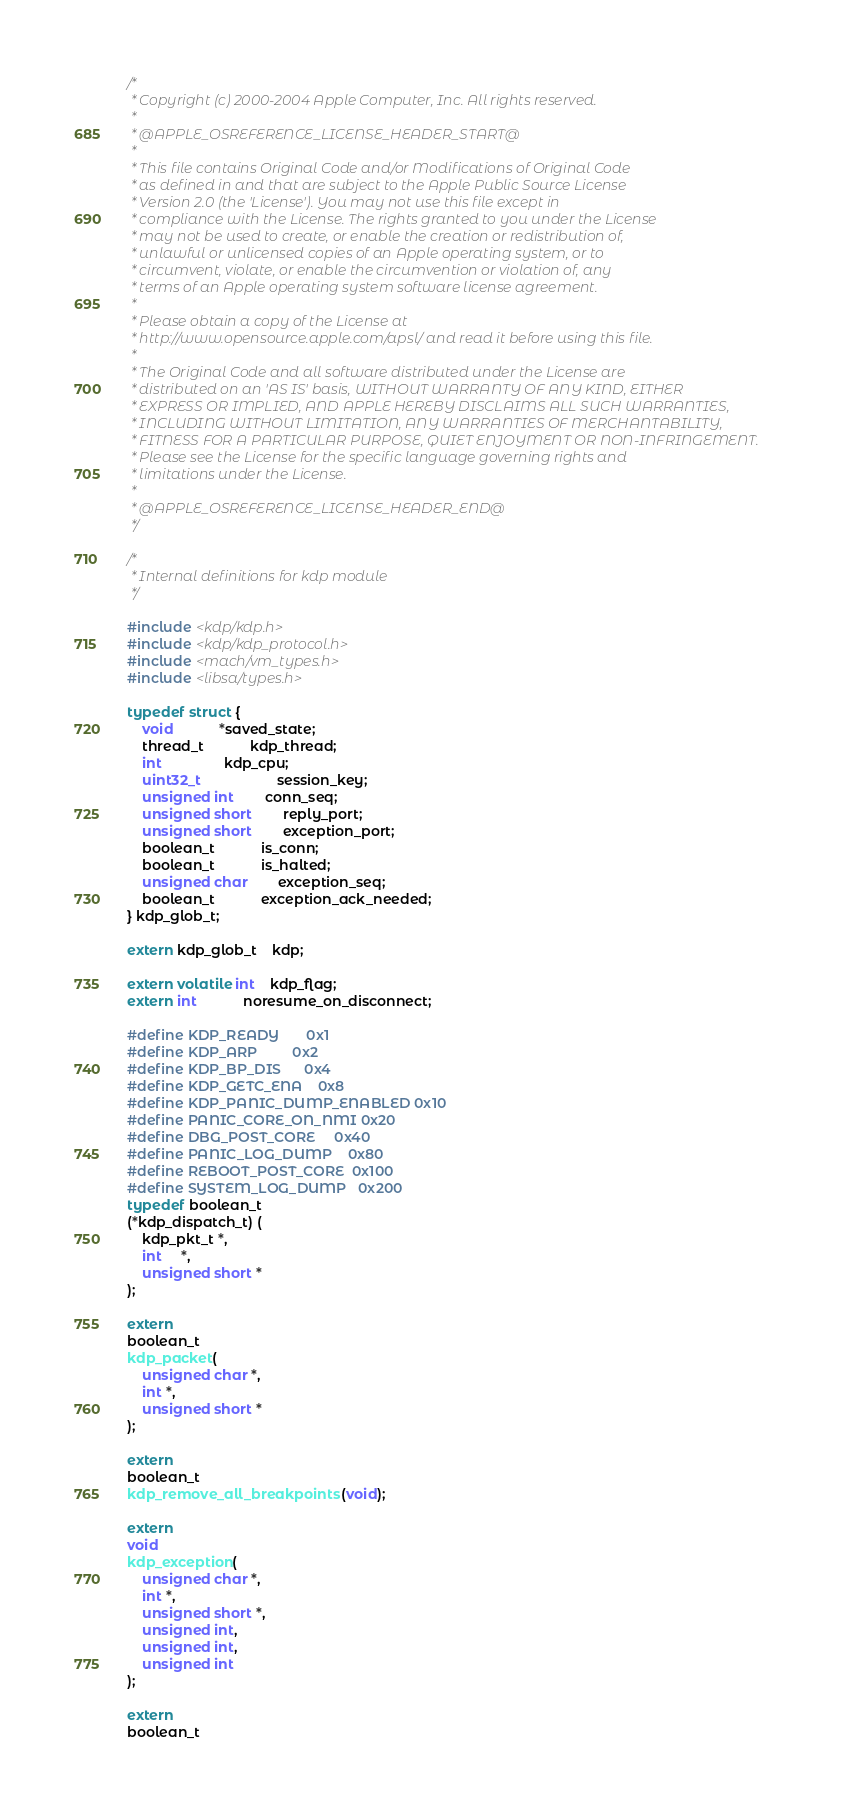Convert code to text. <code><loc_0><loc_0><loc_500><loc_500><_C_>/*
 * Copyright (c) 2000-2004 Apple Computer, Inc. All rights reserved.
 *
 * @APPLE_OSREFERENCE_LICENSE_HEADER_START@
 * 
 * This file contains Original Code and/or Modifications of Original Code
 * as defined in and that are subject to the Apple Public Source License
 * Version 2.0 (the 'License'). You may not use this file except in
 * compliance with the License. The rights granted to you under the License
 * may not be used to create, or enable the creation or redistribution of,
 * unlawful or unlicensed copies of an Apple operating system, or to
 * circumvent, violate, or enable the circumvention or violation of, any
 * terms of an Apple operating system software license agreement.
 * 
 * Please obtain a copy of the License at
 * http://www.opensource.apple.com/apsl/ and read it before using this file.
 * 
 * The Original Code and all software distributed under the License are
 * distributed on an 'AS IS' basis, WITHOUT WARRANTY OF ANY KIND, EITHER
 * EXPRESS OR IMPLIED, AND APPLE HEREBY DISCLAIMS ALL SUCH WARRANTIES,
 * INCLUDING WITHOUT LIMITATION, ANY WARRANTIES OF MERCHANTABILITY,
 * FITNESS FOR A PARTICULAR PURPOSE, QUIET ENJOYMENT OR NON-INFRINGEMENT.
 * Please see the License for the specific language governing rights and
 * limitations under the License.
 * 
 * @APPLE_OSREFERENCE_LICENSE_HEADER_END@
 */

/*
 * Internal definitions for kdp module
 */

#include <kdp/kdp.h>
#include <kdp/kdp_protocol.h>
#include <mach/vm_types.h>
#include <libsa/types.h>

typedef struct {
    void			*saved_state;
    thread_t			kdp_thread;
    int				kdp_cpu;
    uint32_t                    session_key;
    unsigned int		conn_seq;
    unsigned short		reply_port;
    unsigned short		exception_port;
    boolean_t			is_conn;
    boolean_t			is_halted;
    unsigned char		exception_seq;
    boolean_t			exception_ack_needed;
} kdp_glob_t;

extern kdp_glob_t	kdp;

extern volatile int	kdp_flag;
extern int            noresume_on_disconnect;

#define KDP_READY       0x1
#define KDP_ARP         0x2
#define KDP_BP_DIS      0x4
#define KDP_GETC_ENA    0x8
#define KDP_PANIC_DUMP_ENABLED 0x10
#define PANIC_CORE_ON_NMI 0x20 
#define DBG_POST_CORE     0x40
#define PANIC_LOG_DUMP    0x80
#define REBOOT_POST_CORE  0x100
#define SYSTEM_LOG_DUMP   0x200
typedef boolean_t
(*kdp_dispatch_t) (
    kdp_pkt_t *,
    int	 *,
    unsigned short *
);

extern
boolean_t
kdp_packet(
    unsigned char *,
    int *,
    unsigned short *
);

extern
boolean_t
kdp_remove_all_breakpoints (void);

extern
void
kdp_exception(
    unsigned char *,
    int *,
    unsigned short *,
    unsigned int,
    unsigned int,
    unsigned int
);

extern
boolean_t</code> 